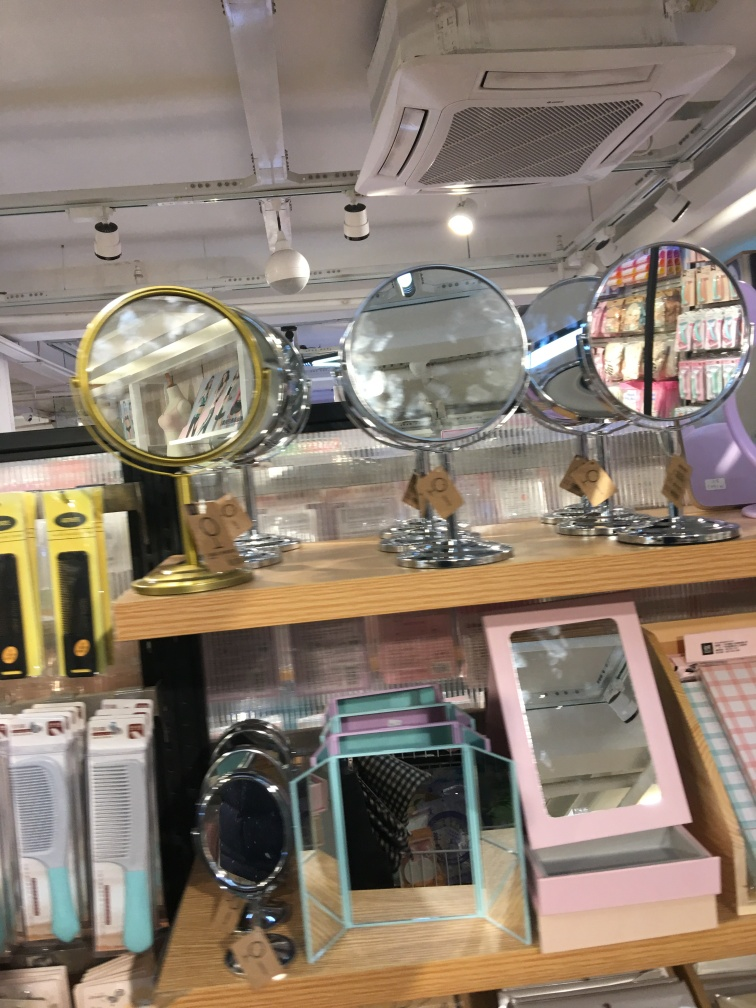Can you tell me what types of items are on display besides the mirrors? Beyond the mirrors, there appear to be personal care items such as hair straighteners and possibly cosmetic products on the shelves behind the mirrors. 